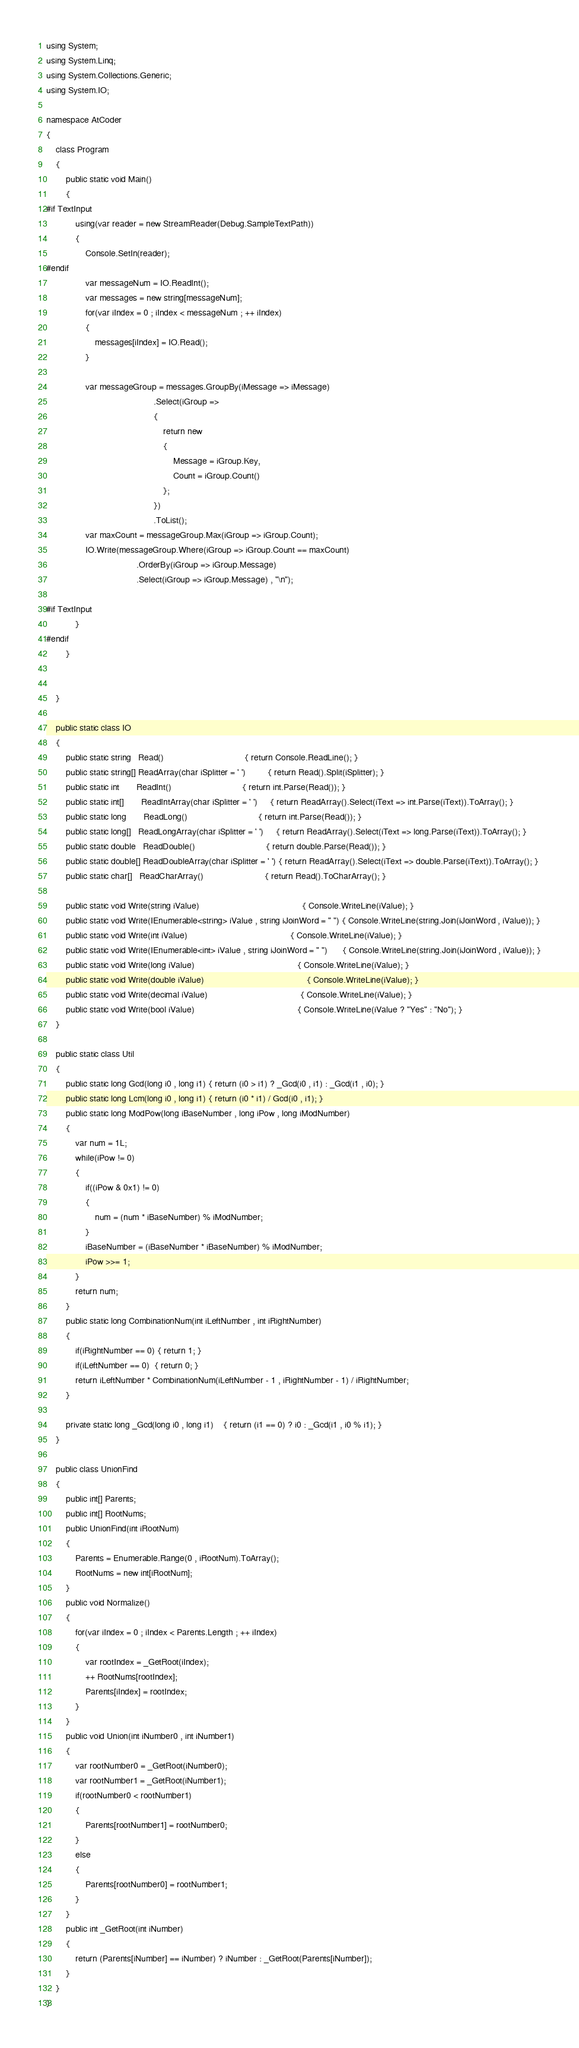<code> <loc_0><loc_0><loc_500><loc_500><_C#_>using System;
using System.Linq;
using System.Collections.Generic;
using System.IO;

namespace AtCoder
{
	class Program
	{
		public static void Main()
		{
#if TextInput
			using(var reader = new StreamReader(Debug.SampleTextPath)) 
			{
				Console.SetIn(reader);
#endif
				var messageNum = IO.ReadInt();
				var messages = new string[messageNum];
				for(var iIndex = 0 ; iIndex < messageNum ; ++ iIndex)
				{
					messages[iIndex] = IO.Read();
				}

				var messageGroup = messages.GroupBy(iMessage => iMessage)
											.Select(iGroup =>
											{
												return new
												{
													Message = iGroup.Key,
													Count = iGroup.Count()
												};
											})
											.ToList();
				var maxCount = messageGroup.Max(iGroup => iGroup.Count);
				IO.Write(messageGroup.Where(iGroup => iGroup.Count == maxCount)
									 .OrderBy(iGroup => iGroup.Message)
									 .Select(iGroup => iGroup.Message) , "\n");
				
#if TextInput
			}
#endif
		}

		
	}

	public static class IO
	{
		public static string   Read()								 { return Console.ReadLine(); }
		public static string[] ReadArray(char iSplitter = ' ')		 { return Read().Split(iSplitter); }
		public static int	   ReadInt()							 { return int.Parse(Read()); }
		public static int[]	   ReadIntArray(char iSplitter = ' ')	 { return ReadArray().Select(iText => int.Parse(iText)).ToArray(); }
		public static long	   ReadLong()							 { return int.Parse(Read()); }
		public static long[]   ReadLongArray(char iSplitter = ' ')	 { return ReadArray().Select(iText => long.Parse(iText)).ToArray(); }
		public static double   ReadDouble()							 { return double.Parse(Read()); }
		public static double[] ReadDoubleArray(char iSplitter = ' ') { return ReadArray().Select(iText => double.Parse(iText)).ToArray(); }
		public static char[]   ReadCharArray()						 { return Read().ToCharArray(); }

		public static void Write(string iValue)										  { Console.WriteLine(iValue); }
		public static void Write(IEnumerable<string> iValue , string iJoinWord = " ") { Console.WriteLine(string.Join(iJoinWord , iValue)); }
		public static void Write(int iValue)										  { Console.WriteLine(iValue); }
		public static void Write(IEnumerable<int> iValue , string iJoinWord = " ")	  { Console.WriteLine(string.Join(iJoinWord , iValue)); }
		public static void Write(long iValue)										  { Console.WriteLine(iValue); }
		public static void Write(double iValue)										  { Console.WriteLine(iValue); }
		public static void Write(decimal iValue)									  { Console.WriteLine(iValue); }
		public static void Write(bool iValue)										  { Console.WriteLine(iValue ? "Yes" : "No"); }
	}

	public static class Util
	{
		public static long Gcd(long i0 , long i1) { return (i0 > i1) ? _Gcd(i0 , i1) : _Gcd(i1 , i0); }
		public static long Lcm(long i0 , long i1) { return (i0 * i1) / Gcd(i0 , i1); }
		public static long ModPow(long iBaseNumber , long iPow , long iModNumber)
		{
			var num = 1L;
			while(iPow != 0)
			{
				if((iPow & 0x1) != 0)
				{
					num = (num * iBaseNumber) % iModNumber;
				}
				iBaseNumber = (iBaseNumber * iBaseNumber) % iModNumber;
				iPow >>= 1;
			}
			return num;
		}
		public static long CombinationNum(int iLeftNumber , int iRightNumber)
		{
			if(iRightNumber == 0) { return 1; }
			if(iLeftNumber == 0)  { return 0; }
			return iLeftNumber * CombinationNum(iLeftNumber - 1 , iRightNumber - 1) / iRightNumber;
		}

		private static long _Gcd(long i0 , long i1)	{ return (i1 == 0) ? i0 : _Gcd(i1 , i0 % i1); }
	}

	public class UnionFind
	{
		public int[] Parents;
		public int[] RootNums;
		public UnionFind(int iRootNum)
		{
			Parents = Enumerable.Range(0 , iRootNum).ToArray();
			RootNums = new int[iRootNum];
		}
		public void Normalize()
		{
			for(var iIndex = 0 ; iIndex < Parents.Length ; ++ iIndex)
			{
				var rootIndex = _GetRoot(iIndex);
				++ RootNums[rootIndex];
				Parents[iIndex] = rootIndex;
			}
		}
		public void Union(int iNumber0 , int iNumber1)
		{
			var rootNumber0 = _GetRoot(iNumber0);
			var rootNumber1 = _GetRoot(iNumber1);
			if(rootNumber0 < rootNumber1)
			{
				Parents[rootNumber1] = rootNumber0;
			}
			else
			{
				Parents[rootNumber0] = rootNumber1;
			}
		}
		public int _GetRoot(int iNumber)
		{
			return (Parents[iNumber] == iNumber) ? iNumber : _GetRoot(Parents[iNumber]);
		}
	}
}
</code> 